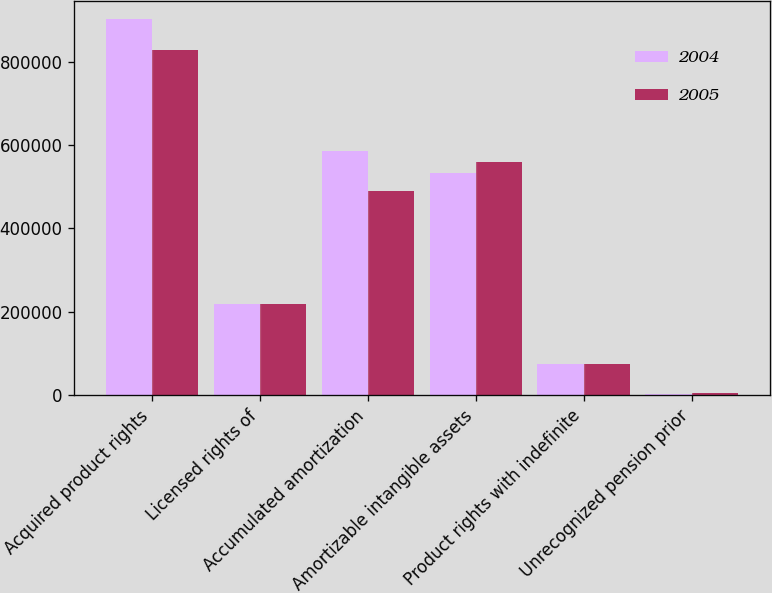Convert chart. <chart><loc_0><loc_0><loc_500><loc_500><stacked_bar_chart><ecel><fcel>Acquired product rights<fcel>Licensed rights of<fcel>Accumulated amortization<fcel>Amortizable intangible assets<fcel>Product rights with indefinite<fcel>Unrecognized pension prior<nl><fcel>2004<fcel>900891<fcel>219071<fcel>586022<fcel>533940<fcel>75738<fcel>3755<nl><fcel>2005<fcel>828186<fcel>219071<fcel>489238<fcel>558019<fcel>75738<fcel>4172<nl></chart> 